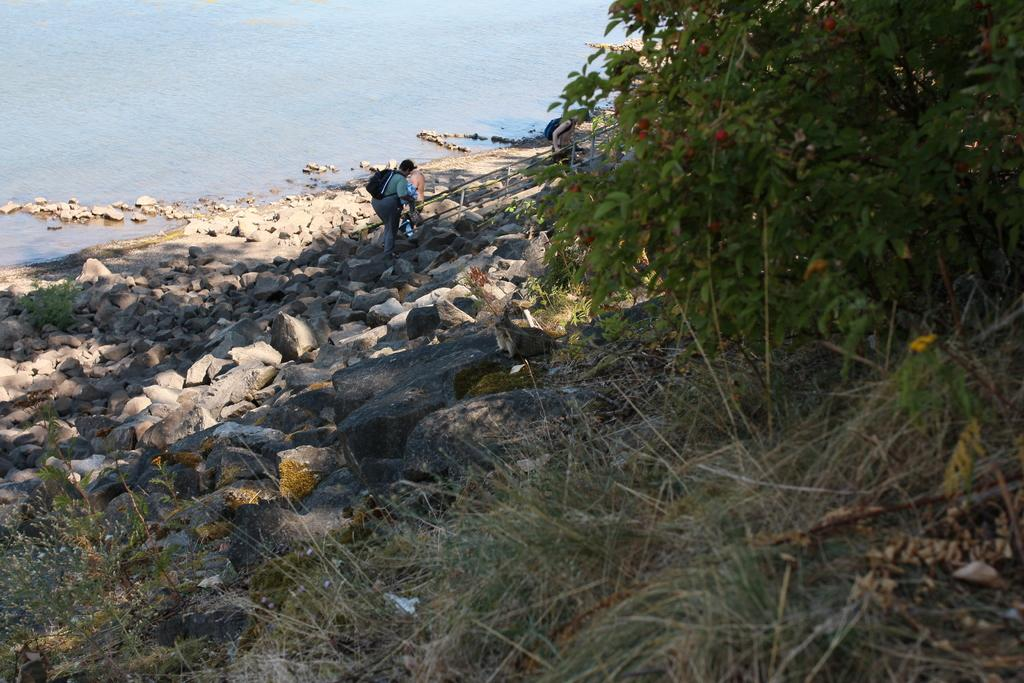What can be seen in the background of the image? There is water and stones in the background of the image. What is the person in the image doing? The person is standing in the image. What is the person carrying on their back? The person is wearing a backpack. What is located on the right side of the image? There is a plant and grass on the right side of the image. Is there a rainstorm happening in the image? No, there is no rainstorm depicted in the image. What type of bag is the person holding in the image? The person is wearing a backpack, not holding a bag. 